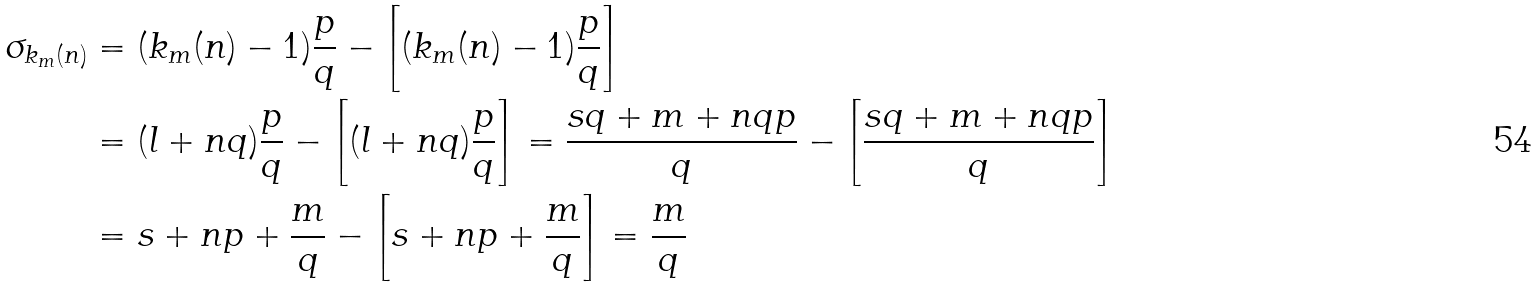Convert formula to latex. <formula><loc_0><loc_0><loc_500><loc_500>\sigma _ { k _ { m } ( n ) } & = ( k _ { m } ( n ) - 1 ) \frac { p } { q } - \left [ ( k _ { m } ( n ) - 1 ) \frac { p } { q } \right ] \\ & = ( l + n q ) \frac { p } { q } - \left [ ( l + n q ) \frac { p } { q } \right ] = \frac { s q + m + n q p } { q } - \left [ \frac { s q + m + n q p } { q } \right ] \\ & = s + n p + \frac { m } { q } - \left [ s + n p + \frac { m } { q } \right ] = \frac { m } { q }</formula> 